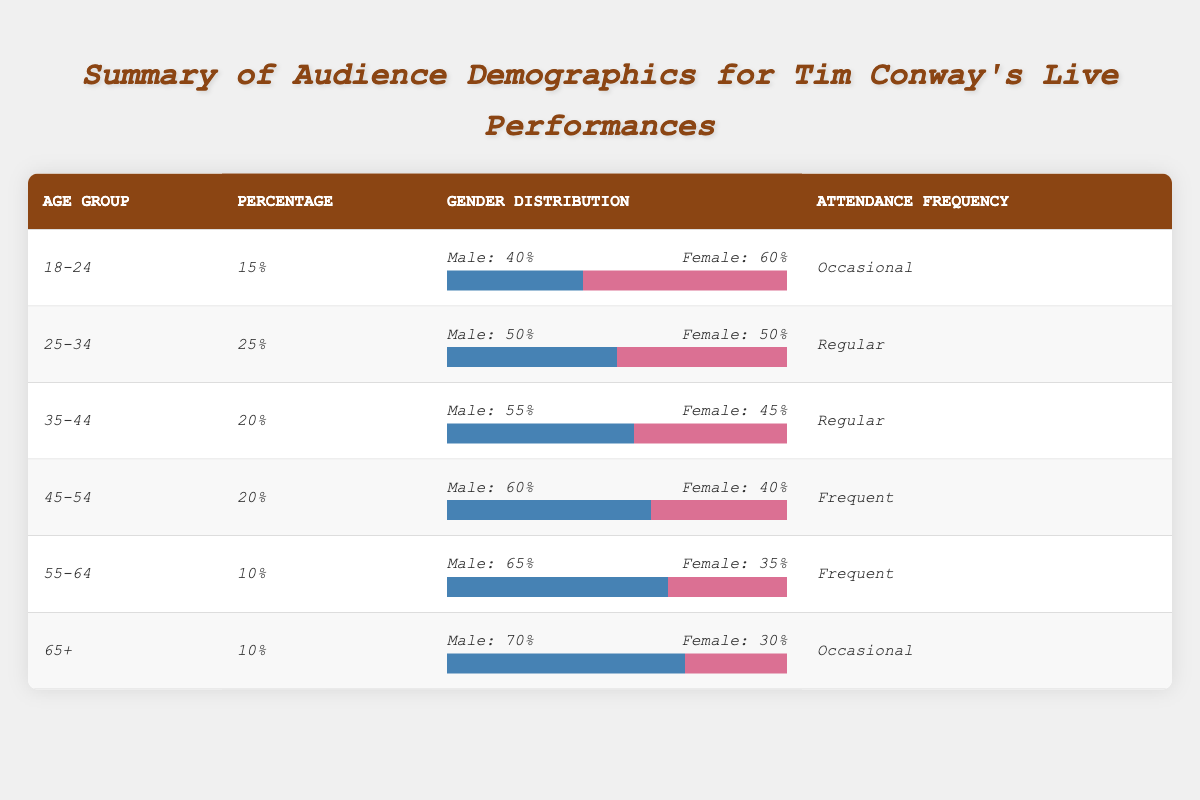What percentage of the audience is aged 18-24? The table indicates that the audience aged 18-24 represents 15%.
Answer: 15% How many age groups have a percentage of 20%? There are two age groups in the table with a percentage of 20%, which are the 35-44 and 45-54 age groups.
Answer: 2 What is the gender distribution for the age group 45-54? For the age group 45-54, the gender distribution is 60% male and 40% female.
Answer: Male: 60%, Female: 40% Which age group has the highest percentage of males? The age group 65+ has the highest percentage of males at 70%.
Answer: 65+ What is the average percentage of the audience across all age groups? The percentages for all age groups are 15%, 25%, 20%, 20%, 10%, and 10%. Summing these gives 15 + 25 + 20 + 20 + 10 + 10 = 110. Dividing by the number of age groups (6), the average is 110/6 ≈ 18.33%.
Answer: 18.33% Is there an equal gender distribution in the 25-34 age group? Yes, the gender distribution for the 25-34 age group is 50% male and 50% female, indicating equal distribution.
Answer: Yes How does the attendance frequency compare for the age groups 25-34 and 35-44? Both age groups 25-34 and 35-44 have the same attendance frequency categorized as "Regular."
Answer: Same frequency What age group has the lowest attendance frequency? The age groups with the lowest attendance frequency are 18-24 and 65+, both categorized as "Occasional."
Answer: 18-24 and 65+ Which age group features the highest percentage of females? The 18-24 age group features the highest percentage of females at 60%.
Answer: 18-24 What is the total percentage of the audience in age groups 55-64 and 65+ combined? The percentages for age groups 55-64 and 65+ are 10% and 10%, respectively. Adding these gives 10 + 10 = 20%.
Answer: 20% 